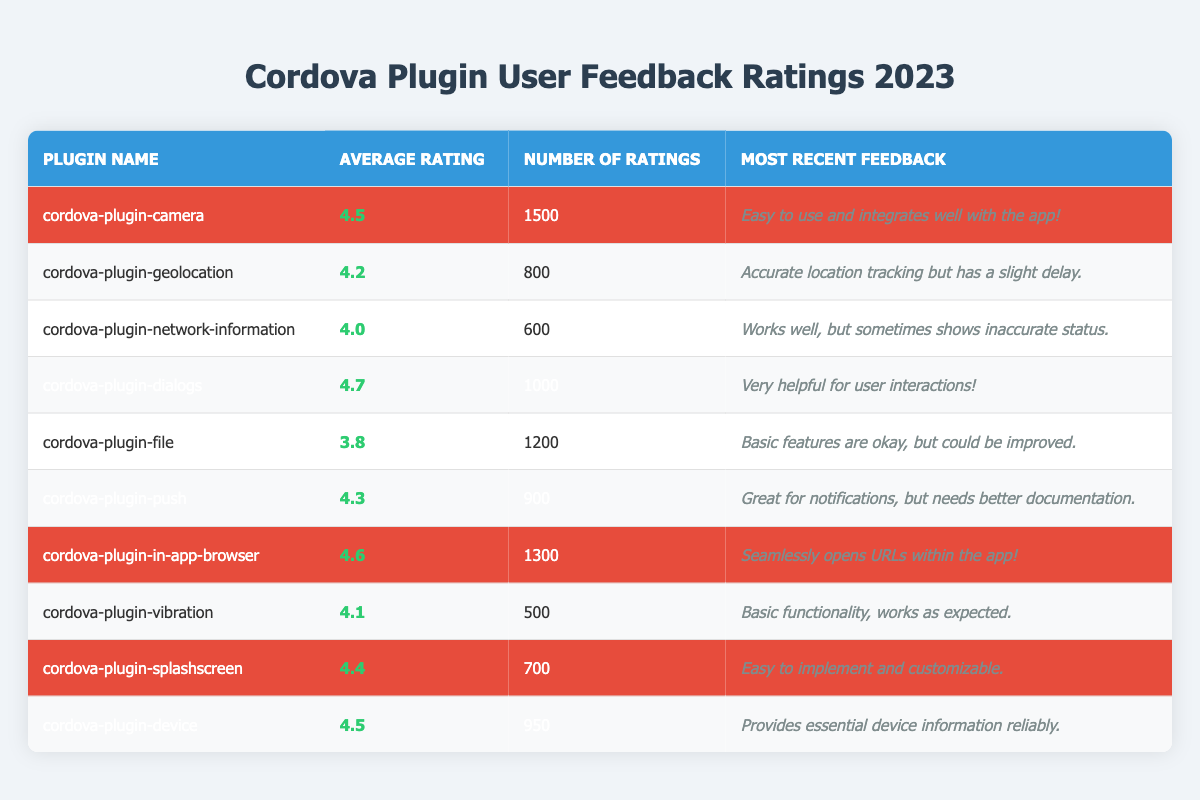What is the highest average rating among the Cordova plugins? The highest average rating is found in the "cordova-plugin-dialogs," which has an average rating of 4.7.
Answer: 4.7 How many ratings did the "cordova-plugin-camera" receive? The "cordova-plugin-camera" received a total of 1500 ratings as indicated in the table.
Answer: 1500 Is the average rating of "cordova-plugin-file" above 4.0? The average rating for "cordova-plugin-file" is 3.8, which is below 4.0.
Answer: No Which plugin has the most recent feedback stating it is "Easy to implement and customizable"? The most recent feedback of "Easy to implement and customizable" belongs to "cordova-plugin-splashscreen" as highlighted in the table.
Answer: cordova-plugin-splashscreen What is the total number of ratings for all highlighted plugins? The highlighted plugins are: "cordova-plugin-camera" (1500), "cordova-plugin-dialogs" (1000), "cordova-plugin-push" (900), "cordova-plugin-in-app-browser" (1300), "cordova-plugin-splashscreen" (700), and "cordova-plugin-device" (950). Summing these gives us 1500 + 1000 + 900 + 1300 + 700 + 950 = 5350 ratings total.
Answer: 5350 How does the average rating of "cordova-plugin-device" compare to that of "cordova-plugin-geolocation"? The average rating for "cordova-plugin-device" is 4.5, while "cordova-plugin-geolocation" has an average rating of 4.2. Since 4.5 is greater than 4.2, "cordova-plugin-device" has a higher rating.
Answer: Higher Which plugins received the average rating of 4.4 or above? The plugins with an average rating of 4.4 or above are: "cordova-plugin-dialogs" (4.7), "cordova-plugin-in-app-browser" (4.6), "cordova-plugin-splashscreen" (4.4), "cordova-plugin-camera" (4.5), and "cordova-plugin-device" (4.5).
Answer: 5 plugins Calculate the average rating of the non-highlighted plugins. The non-highlighted plugins and their ratings are: "cordova-plugin-geolocation" (4.2), "cordova-plugin-network-information" (4.0), "cordova-plugin-file" (3.8), and "cordova-plugin-vibration" (4.1). The sum is 4.2 + 4.0 + 3.8 + 4.1 = 16.1, and there are 4 plugins, so the average is 16.1 / 4 = 4.025.
Answer: 4.025 Which plugin has the least number of ratings, and what is that number? The plugin with the least number of ratings is "cordova-plugin-vibration," which has 500 ratings according to the table.
Answer: 500 How many plugins have received a total of more than 1000 ratings? The plugins that received more than 1000 ratings are: "cordova-plugin-camera" (1500), "cordova-plugin-dialogs" (1000), and "cordova-plugin-in-app-browser" (1300). Counting them gives us 3 plugins.
Answer: 3 